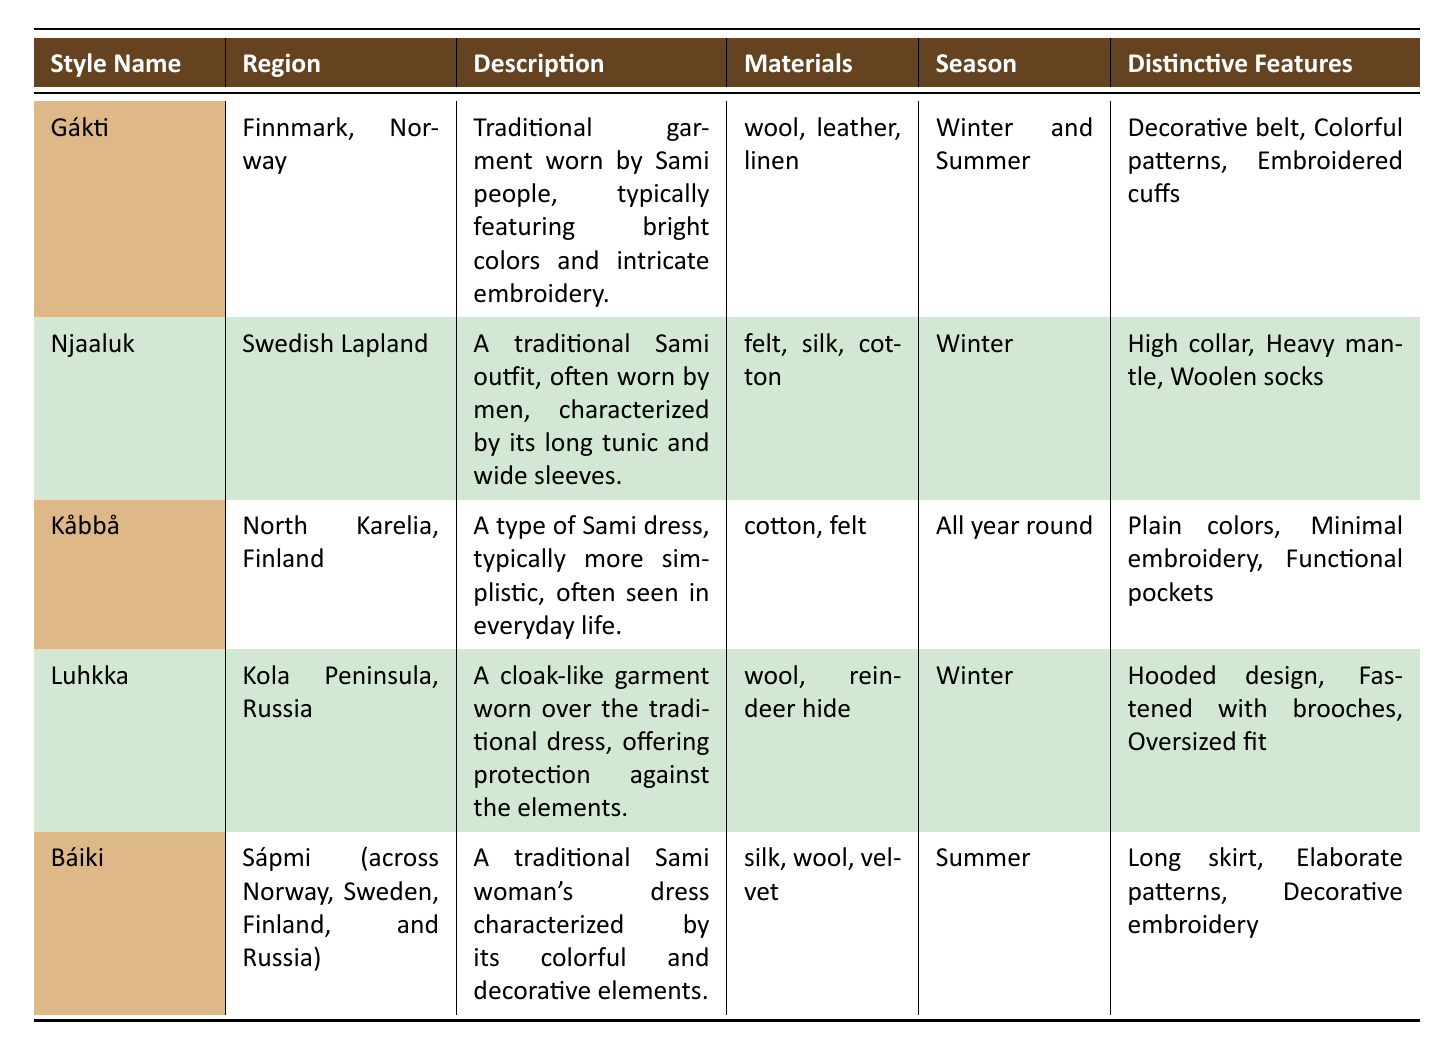What is the distinctive feature of Gákti? The distinctive features of Gákti are listed in the table as "Decorative belt, Colorful patterns, Embroidered cuffs".
Answer: Decorative belt, Colorful patterns, Embroidered cuffs In which region is Njaaluk traditionally worn? The region associated with Njaaluk, as per the table, is "Swedish Lapland".
Answer: Swedish Lapland Is Kåbbå worn in the winter season? According to the table, Kåbbå is noted to be worn "All year round", which means it is not limited to the winter season.
Answer: No How many styles are characterized by the use of wool? The table lists Gákti, Luhkka, and Báiki, which includes wool among its materials. This totals to three styles.
Answer: 3 Which clothing style is associated with the Kola Peninsula in Russia? The corresponding clothing style listed in the table for the Kola Peninsula, Russia, is "Luhkka".
Answer: Luhkka Which clothing style features a high collar? The style indicated in the table with a "High collar" as a distinctive feature is "Njaaluk".
Answer: Njaaluk Which styles are suitable for summer? The table specifies that Gákti is suitable for both winter and summer and Báiki is suitable for summer. Hence, there are two styles for summer.
Answer: 2 What material is used in the construction of Luhkka? The materials listed in the table for Luhkka include "wool" and "reindeer hide".
Answer: Wool, reindeer hide Does Báiki have minimal embroidery? The table indicates that Báiki features "Elaborate patterns, Decorative embroidery", which suggests that it does not have minimal embroidery.
Answer: No Which Sami clothing style has a hooded design? The distinctive feature listed for Luhkka is "Hooded design", indicating that Luhkka is the style with this feature.
Answer: Luhkka 